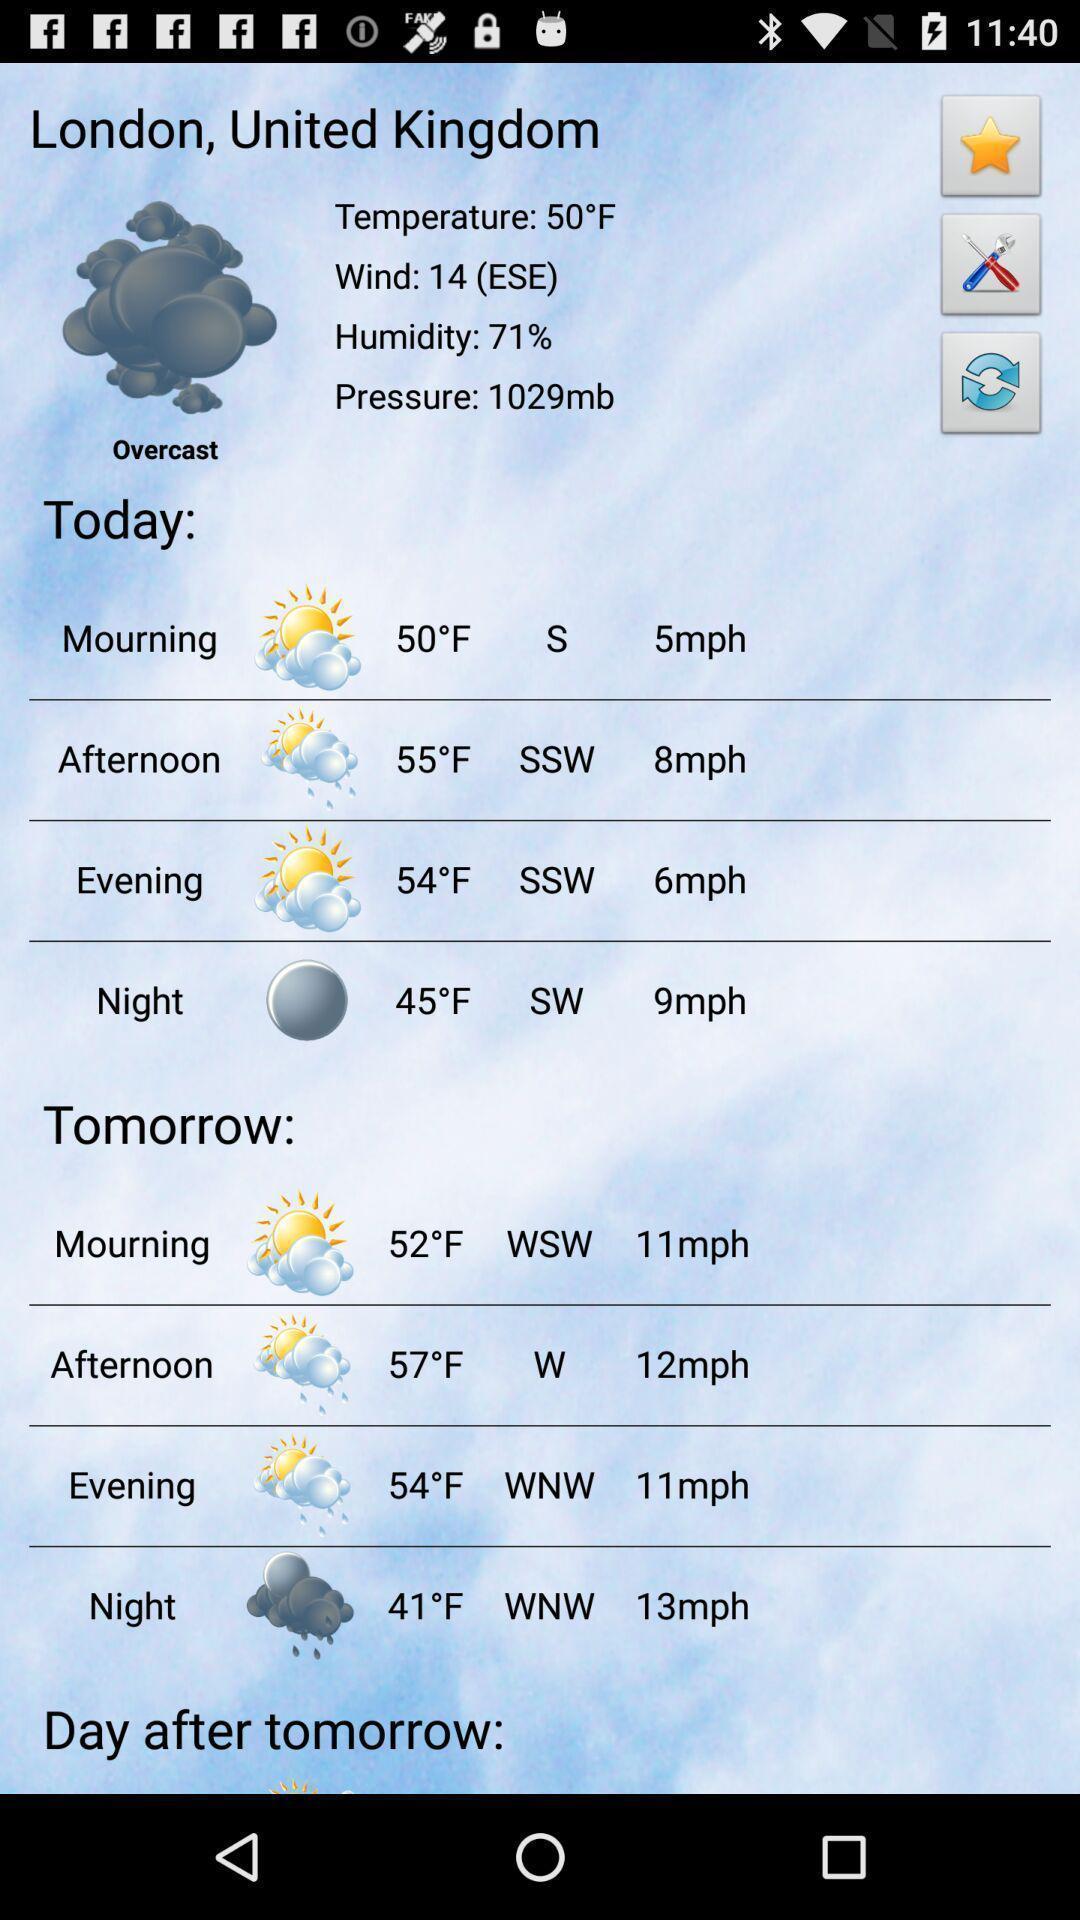Tell me about the visual elements in this screen capture. Various weather details displayed of a city in forecast app. 